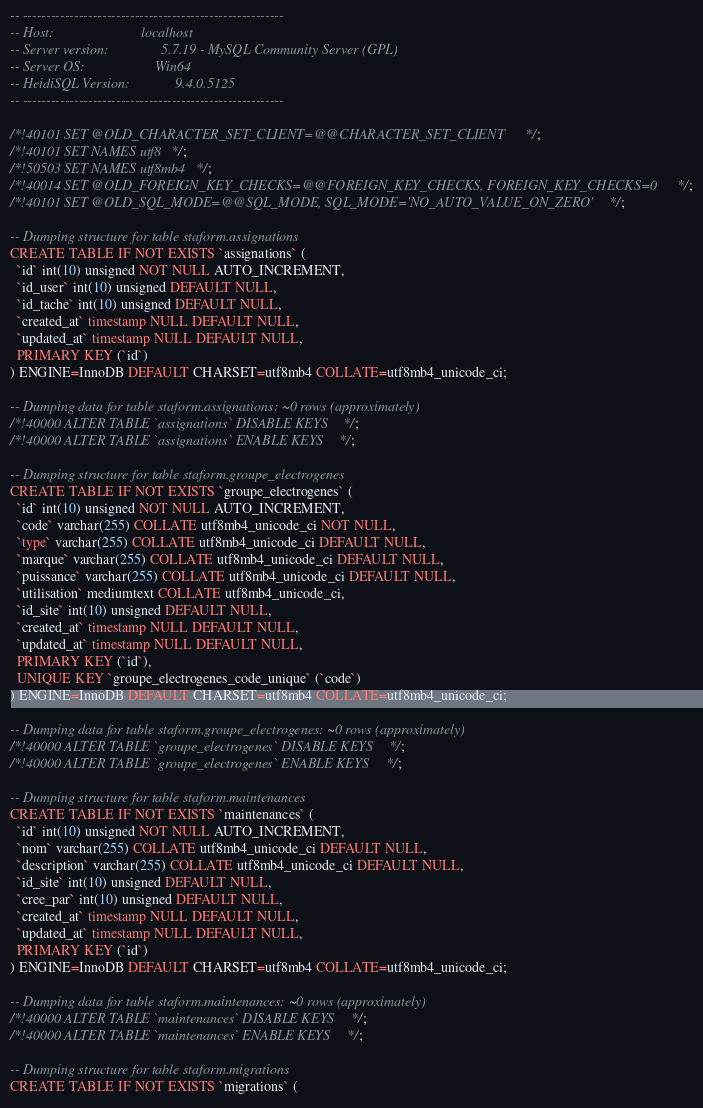<code> <loc_0><loc_0><loc_500><loc_500><_SQL_>-- --------------------------------------------------------
-- Host:                         localhost
-- Server version:               5.7.19 - MySQL Community Server (GPL)
-- Server OS:                    Win64
-- HeidiSQL Version:             9.4.0.5125
-- --------------------------------------------------------

/*!40101 SET @OLD_CHARACTER_SET_CLIENT=@@CHARACTER_SET_CLIENT */;
/*!40101 SET NAMES utf8 */;
/*!50503 SET NAMES utf8mb4 */;
/*!40014 SET @OLD_FOREIGN_KEY_CHECKS=@@FOREIGN_KEY_CHECKS, FOREIGN_KEY_CHECKS=0 */;
/*!40101 SET @OLD_SQL_MODE=@@SQL_MODE, SQL_MODE='NO_AUTO_VALUE_ON_ZERO' */;

-- Dumping structure for table staform.assignations
CREATE TABLE IF NOT EXISTS `assignations` (
  `id` int(10) unsigned NOT NULL AUTO_INCREMENT,
  `id_user` int(10) unsigned DEFAULT NULL,
  `id_tache` int(10) unsigned DEFAULT NULL,
  `created_at` timestamp NULL DEFAULT NULL,
  `updated_at` timestamp NULL DEFAULT NULL,
  PRIMARY KEY (`id`)
) ENGINE=InnoDB DEFAULT CHARSET=utf8mb4 COLLATE=utf8mb4_unicode_ci;

-- Dumping data for table staform.assignations: ~0 rows (approximately)
/*!40000 ALTER TABLE `assignations` DISABLE KEYS */;
/*!40000 ALTER TABLE `assignations` ENABLE KEYS */;

-- Dumping structure for table staform.groupe_electrogenes
CREATE TABLE IF NOT EXISTS `groupe_electrogenes` (
  `id` int(10) unsigned NOT NULL AUTO_INCREMENT,
  `code` varchar(255) COLLATE utf8mb4_unicode_ci NOT NULL,
  `type` varchar(255) COLLATE utf8mb4_unicode_ci DEFAULT NULL,
  `marque` varchar(255) COLLATE utf8mb4_unicode_ci DEFAULT NULL,
  `puissance` varchar(255) COLLATE utf8mb4_unicode_ci DEFAULT NULL,
  `utilisation` mediumtext COLLATE utf8mb4_unicode_ci,
  `id_site` int(10) unsigned DEFAULT NULL,
  `created_at` timestamp NULL DEFAULT NULL,
  `updated_at` timestamp NULL DEFAULT NULL,
  PRIMARY KEY (`id`),
  UNIQUE KEY `groupe_electrogenes_code_unique` (`code`)
) ENGINE=InnoDB DEFAULT CHARSET=utf8mb4 COLLATE=utf8mb4_unicode_ci;

-- Dumping data for table staform.groupe_electrogenes: ~0 rows (approximately)
/*!40000 ALTER TABLE `groupe_electrogenes` DISABLE KEYS */;
/*!40000 ALTER TABLE `groupe_electrogenes` ENABLE KEYS */;

-- Dumping structure for table staform.maintenances
CREATE TABLE IF NOT EXISTS `maintenances` (
  `id` int(10) unsigned NOT NULL AUTO_INCREMENT,
  `nom` varchar(255) COLLATE utf8mb4_unicode_ci DEFAULT NULL,
  `description` varchar(255) COLLATE utf8mb4_unicode_ci DEFAULT NULL,
  `id_site` int(10) unsigned DEFAULT NULL,
  `cree_par` int(10) unsigned DEFAULT NULL,
  `created_at` timestamp NULL DEFAULT NULL,
  `updated_at` timestamp NULL DEFAULT NULL,
  PRIMARY KEY (`id`)
) ENGINE=InnoDB DEFAULT CHARSET=utf8mb4 COLLATE=utf8mb4_unicode_ci;

-- Dumping data for table staform.maintenances: ~0 rows (approximately)
/*!40000 ALTER TABLE `maintenances` DISABLE KEYS */;
/*!40000 ALTER TABLE `maintenances` ENABLE KEYS */;

-- Dumping structure for table staform.migrations
CREATE TABLE IF NOT EXISTS `migrations` (</code> 